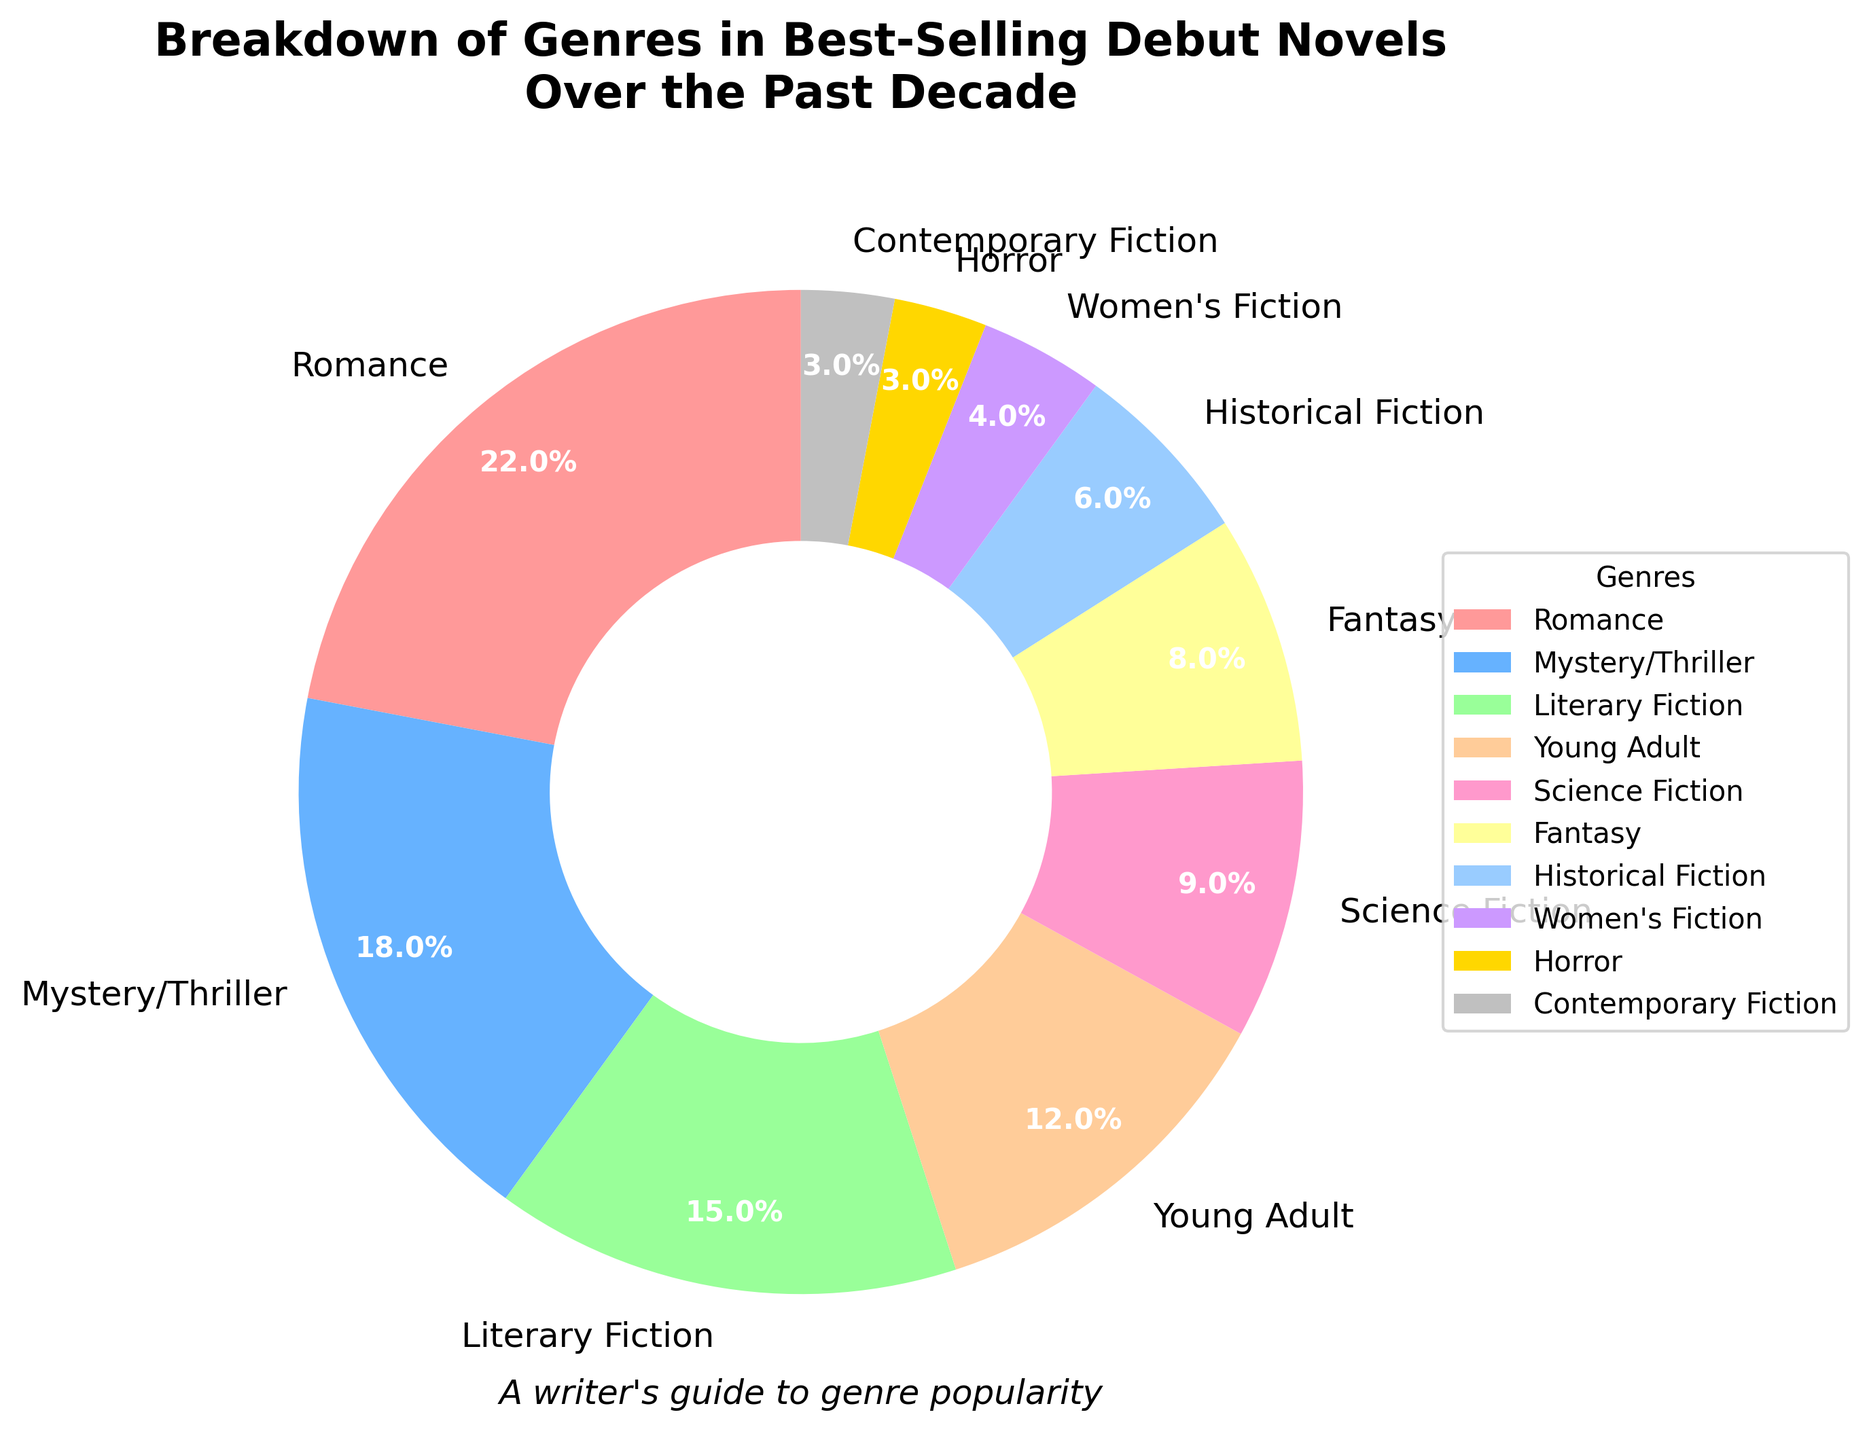What genre has the highest percentage in best-selling debut novels? By looking at the pie chart, the largest section appears to be for Romance, occupying the biggest slice of the pie.
Answer: Romance How much greater is the percentage of Young Adult novels compared to Horror novels? The percentage of Young Adult novels is 12%, and the percentage of Horror novels is 3%. To find the difference, subtract 3 from 12.
Answer: 9% Which genre has the second-highest percentage, and what is the percentage? The second-largest slice after Romance is for Mystery/Thriller, which has 18%.
Answer: Mystery/Thriller, 18% What is the combined percentage of genres with less than 5% each? The genres with less than 5% are Women's Fiction (4%), Horror (3%), and Contemporary Fiction (3%). Add these percentages together: 4 + 3 + 3 = 10%.
Answer: 10% Is the percentage of Science Fiction greater than or less than the percentage of Fantasy? By looking at the chart, Science Fiction has 9%, and Fantasy has 8%. Since 9 is greater than 8, Science Fiction has a higher percentage.
Answer: Greater How many genres have a percentage over 10%? By referring to the pie chart, the genres over 10% are Romance, Mystery/Thriller, Literary Fiction, and Young Adult. Counting them gives us 4 genres.
Answer: 4 What is the visual color representing Contemporary Fiction, and what is its percentage? Contemporary Fiction is represented by a silver-gray color in the pie chart, and it has a percentage of 3%.
Answer: Silver-gray, 3% What is the cumulative percentage of Mystery/Thriller and Fantasy combined? Mystery/Thriller has 18%, and Fantasy has 8%. Adding these together provides the cumulative percentage: 18 + 8 = 26%.
Answer: 26% Which genre has the least percentage, and what is the color representing it? The genre with the smallest percentage is Horror, which has 3%. In the pie chart, this genre is represented by a golden-yellow color.
Answer: Horror, golden-yellow If you were to write a novel in a genre that is not among the top three in percentages, which genres could you choose from? The top three genres by percentage are Romance (22%), Mystery/Thriller (18%), and Literary Fiction (15%). Excluding these, the available genres are Young Adult, Science Fiction, Fantasy, Historical Fiction, Women's Fiction, Horror, and Contemporary Fiction.
Answer: Young Adult, Science Fiction, Fantasy, Historical Fiction, Women's Fiction, Horror, Contemporary Fiction 